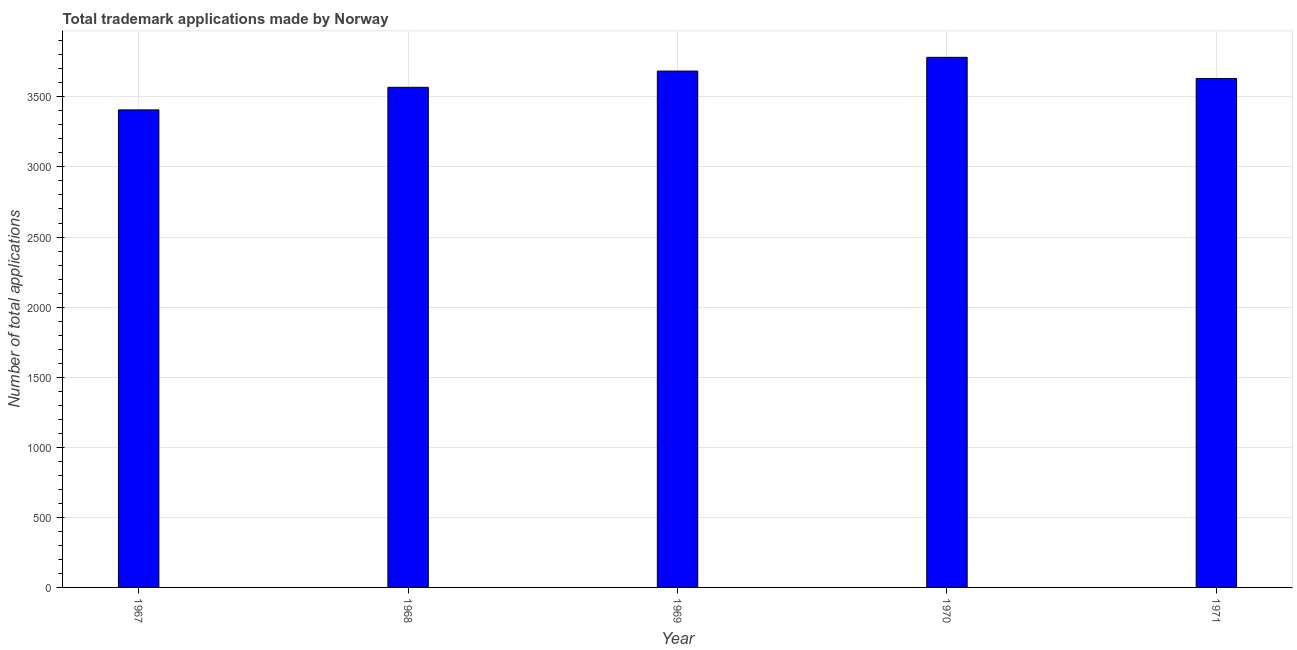Does the graph contain grids?
Your answer should be compact. Yes. What is the title of the graph?
Give a very brief answer. Total trademark applications made by Norway. What is the label or title of the X-axis?
Your answer should be compact. Year. What is the label or title of the Y-axis?
Your answer should be compact. Number of total applications. What is the number of trademark applications in 1968?
Provide a succinct answer. 3568. Across all years, what is the maximum number of trademark applications?
Give a very brief answer. 3782. Across all years, what is the minimum number of trademark applications?
Your response must be concise. 3407. In which year was the number of trademark applications maximum?
Offer a terse response. 1970. In which year was the number of trademark applications minimum?
Your answer should be very brief. 1967. What is the sum of the number of trademark applications?
Your response must be concise. 1.81e+04. What is the difference between the number of trademark applications in 1967 and 1971?
Your answer should be very brief. -224. What is the average number of trademark applications per year?
Your response must be concise. 3614. What is the median number of trademark applications?
Your answer should be very brief. 3631. In how many years, is the number of trademark applications greater than 2800 ?
Your response must be concise. 5. Is the difference between the number of trademark applications in 1967 and 1968 greater than the difference between any two years?
Keep it short and to the point. No. Is the sum of the number of trademark applications in 1967 and 1970 greater than the maximum number of trademark applications across all years?
Ensure brevity in your answer.  Yes. What is the difference between the highest and the lowest number of trademark applications?
Your answer should be compact. 375. How many years are there in the graph?
Make the answer very short. 5. What is the difference between two consecutive major ticks on the Y-axis?
Provide a short and direct response. 500. What is the Number of total applications of 1967?
Provide a short and direct response. 3407. What is the Number of total applications in 1968?
Give a very brief answer. 3568. What is the Number of total applications in 1969?
Give a very brief answer. 3684. What is the Number of total applications in 1970?
Keep it short and to the point. 3782. What is the Number of total applications in 1971?
Give a very brief answer. 3631. What is the difference between the Number of total applications in 1967 and 1968?
Offer a terse response. -161. What is the difference between the Number of total applications in 1967 and 1969?
Make the answer very short. -277. What is the difference between the Number of total applications in 1967 and 1970?
Keep it short and to the point. -375. What is the difference between the Number of total applications in 1967 and 1971?
Your answer should be compact. -224. What is the difference between the Number of total applications in 1968 and 1969?
Offer a terse response. -116. What is the difference between the Number of total applications in 1968 and 1970?
Give a very brief answer. -214. What is the difference between the Number of total applications in 1968 and 1971?
Give a very brief answer. -63. What is the difference between the Number of total applications in 1969 and 1970?
Your answer should be very brief. -98. What is the difference between the Number of total applications in 1969 and 1971?
Provide a succinct answer. 53. What is the difference between the Number of total applications in 1970 and 1971?
Make the answer very short. 151. What is the ratio of the Number of total applications in 1967 to that in 1968?
Provide a short and direct response. 0.95. What is the ratio of the Number of total applications in 1967 to that in 1969?
Offer a terse response. 0.93. What is the ratio of the Number of total applications in 1967 to that in 1970?
Your answer should be compact. 0.9. What is the ratio of the Number of total applications in 1967 to that in 1971?
Your answer should be very brief. 0.94. What is the ratio of the Number of total applications in 1968 to that in 1970?
Your answer should be compact. 0.94. What is the ratio of the Number of total applications in 1969 to that in 1971?
Your answer should be very brief. 1.01. What is the ratio of the Number of total applications in 1970 to that in 1971?
Make the answer very short. 1.04. 